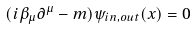Convert formula to latex. <formula><loc_0><loc_0><loc_500><loc_500>( i \beta _ { \mu } \partial ^ { \mu } - m ) \psi _ { i n , o u t } ( x ) = 0</formula> 